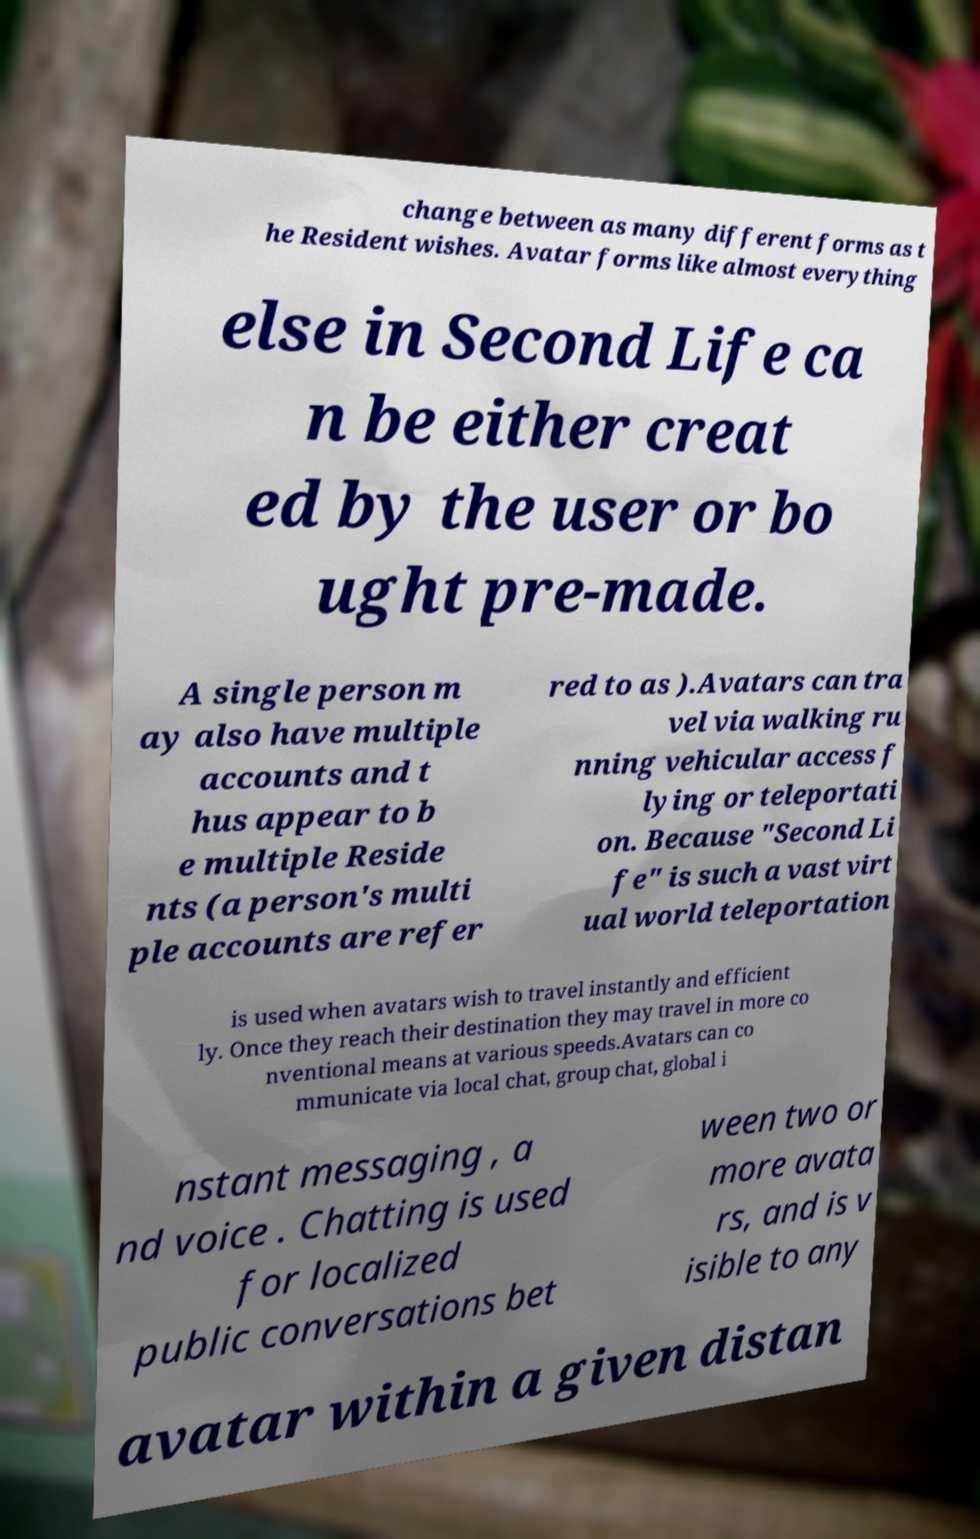Can you read and provide the text displayed in the image?This photo seems to have some interesting text. Can you extract and type it out for me? change between as many different forms as t he Resident wishes. Avatar forms like almost everything else in Second Life ca n be either creat ed by the user or bo ught pre-made. A single person m ay also have multiple accounts and t hus appear to b e multiple Reside nts (a person's multi ple accounts are refer red to as ).Avatars can tra vel via walking ru nning vehicular access f lying or teleportati on. Because "Second Li fe" is such a vast virt ual world teleportation is used when avatars wish to travel instantly and efficient ly. Once they reach their destination they may travel in more co nventional means at various speeds.Avatars can co mmunicate via local chat, group chat, global i nstant messaging , a nd voice . Chatting is used for localized public conversations bet ween two or more avata rs, and is v isible to any avatar within a given distan 